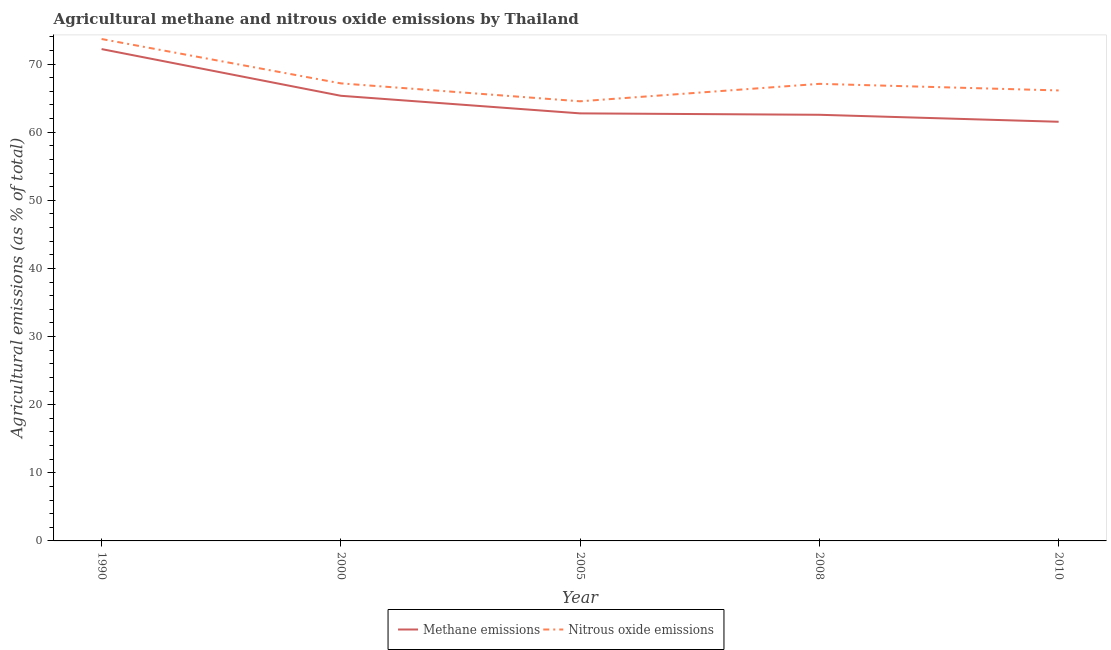How many different coloured lines are there?
Keep it short and to the point. 2. What is the amount of nitrous oxide emissions in 1990?
Keep it short and to the point. 73.67. Across all years, what is the maximum amount of methane emissions?
Make the answer very short. 72.19. Across all years, what is the minimum amount of nitrous oxide emissions?
Make the answer very short. 64.53. In which year was the amount of methane emissions minimum?
Provide a short and direct response. 2010. What is the total amount of nitrous oxide emissions in the graph?
Make the answer very short. 338.58. What is the difference between the amount of nitrous oxide emissions in 1990 and that in 2010?
Keep it short and to the point. 7.55. What is the difference between the amount of methane emissions in 2008 and the amount of nitrous oxide emissions in 2010?
Your answer should be compact. -3.57. What is the average amount of nitrous oxide emissions per year?
Give a very brief answer. 67.72. In the year 2008, what is the difference between the amount of nitrous oxide emissions and amount of methane emissions?
Offer a terse response. 4.54. In how many years, is the amount of methane emissions greater than 72 %?
Offer a very short reply. 1. What is the ratio of the amount of methane emissions in 1990 to that in 2005?
Ensure brevity in your answer.  1.15. Is the amount of nitrous oxide emissions in 1990 less than that in 2010?
Offer a very short reply. No. What is the difference between the highest and the second highest amount of nitrous oxide emissions?
Keep it short and to the point. 6.51. What is the difference between the highest and the lowest amount of nitrous oxide emissions?
Provide a succinct answer. 9.14. In how many years, is the amount of methane emissions greater than the average amount of methane emissions taken over all years?
Your answer should be very brief. 2. Is the sum of the amount of methane emissions in 2000 and 2005 greater than the maximum amount of nitrous oxide emissions across all years?
Offer a very short reply. Yes. Does the amount of methane emissions monotonically increase over the years?
Your answer should be very brief. No. Does the graph contain grids?
Your answer should be compact. No. Where does the legend appear in the graph?
Provide a short and direct response. Bottom center. How many legend labels are there?
Your answer should be very brief. 2. How are the legend labels stacked?
Give a very brief answer. Horizontal. What is the title of the graph?
Make the answer very short. Agricultural methane and nitrous oxide emissions by Thailand. What is the label or title of the X-axis?
Your answer should be compact. Year. What is the label or title of the Y-axis?
Your answer should be very brief. Agricultural emissions (as % of total). What is the Agricultural emissions (as % of total) in Methane emissions in 1990?
Provide a short and direct response. 72.19. What is the Agricultural emissions (as % of total) of Nitrous oxide emissions in 1990?
Offer a very short reply. 73.67. What is the Agricultural emissions (as % of total) in Methane emissions in 2000?
Offer a very short reply. 65.34. What is the Agricultural emissions (as % of total) of Nitrous oxide emissions in 2000?
Your answer should be very brief. 67.16. What is the Agricultural emissions (as % of total) of Methane emissions in 2005?
Your response must be concise. 62.76. What is the Agricultural emissions (as % of total) in Nitrous oxide emissions in 2005?
Give a very brief answer. 64.53. What is the Agricultural emissions (as % of total) in Methane emissions in 2008?
Offer a very short reply. 62.55. What is the Agricultural emissions (as % of total) of Nitrous oxide emissions in 2008?
Provide a succinct answer. 67.09. What is the Agricultural emissions (as % of total) of Methane emissions in 2010?
Provide a short and direct response. 61.53. What is the Agricultural emissions (as % of total) of Nitrous oxide emissions in 2010?
Make the answer very short. 66.12. Across all years, what is the maximum Agricultural emissions (as % of total) in Methane emissions?
Your answer should be very brief. 72.19. Across all years, what is the maximum Agricultural emissions (as % of total) in Nitrous oxide emissions?
Offer a terse response. 73.67. Across all years, what is the minimum Agricultural emissions (as % of total) in Methane emissions?
Offer a terse response. 61.53. Across all years, what is the minimum Agricultural emissions (as % of total) of Nitrous oxide emissions?
Your answer should be very brief. 64.53. What is the total Agricultural emissions (as % of total) in Methane emissions in the graph?
Provide a short and direct response. 324.37. What is the total Agricultural emissions (as % of total) in Nitrous oxide emissions in the graph?
Ensure brevity in your answer.  338.58. What is the difference between the Agricultural emissions (as % of total) in Methane emissions in 1990 and that in 2000?
Make the answer very short. 6.85. What is the difference between the Agricultural emissions (as % of total) in Nitrous oxide emissions in 1990 and that in 2000?
Keep it short and to the point. 6.51. What is the difference between the Agricultural emissions (as % of total) of Methane emissions in 1990 and that in 2005?
Give a very brief answer. 9.44. What is the difference between the Agricultural emissions (as % of total) of Nitrous oxide emissions in 1990 and that in 2005?
Your response must be concise. 9.14. What is the difference between the Agricultural emissions (as % of total) in Methane emissions in 1990 and that in 2008?
Offer a very short reply. 9.64. What is the difference between the Agricultural emissions (as % of total) in Nitrous oxide emissions in 1990 and that in 2008?
Give a very brief answer. 6.58. What is the difference between the Agricultural emissions (as % of total) in Methane emissions in 1990 and that in 2010?
Your answer should be compact. 10.67. What is the difference between the Agricultural emissions (as % of total) in Nitrous oxide emissions in 1990 and that in 2010?
Your answer should be compact. 7.55. What is the difference between the Agricultural emissions (as % of total) of Methane emissions in 2000 and that in 2005?
Provide a succinct answer. 2.58. What is the difference between the Agricultural emissions (as % of total) in Nitrous oxide emissions in 2000 and that in 2005?
Ensure brevity in your answer.  2.63. What is the difference between the Agricultural emissions (as % of total) in Methane emissions in 2000 and that in 2008?
Ensure brevity in your answer.  2.79. What is the difference between the Agricultural emissions (as % of total) in Nitrous oxide emissions in 2000 and that in 2008?
Offer a terse response. 0.07. What is the difference between the Agricultural emissions (as % of total) in Methane emissions in 2000 and that in 2010?
Make the answer very short. 3.81. What is the difference between the Agricultural emissions (as % of total) of Nitrous oxide emissions in 2000 and that in 2010?
Offer a very short reply. 1.04. What is the difference between the Agricultural emissions (as % of total) of Methane emissions in 2005 and that in 2008?
Ensure brevity in your answer.  0.21. What is the difference between the Agricultural emissions (as % of total) in Nitrous oxide emissions in 2005 and that in 2008?
Provide a succinct answer. -2.56. What is the difference between the Agricultural emissions (as % of total) in Methane emissions in 2005 and that in 2010?
Give a very brief answer. 1.23. What is the difference between the Agricultural emissions (as % of total) of Nitrous oxide emissions in 2005 and that in 2010?
Ensure brevity in your answer.  -1.59. What is the difference between the Agricultural emissions (as % of total) of Methane emissions in 2008 and that in 2010?
Offer a very short reply. 1.02. What is the difference between the Agricultural emissions (as % of total) in Nitrous oxide emissions in 2008 and that in 2010?
Provide a short and direct response. 0.97. What is the difference between the Agricultural emissions (as % of total) of Methane emissions in 1990 and the Agricultural emissions (as % of total) of Nitrous oxide emissions in 2000?
Offer a very short reply. 5.03. What is the difference between the Agricultural emissions (as % of total) in Methane emissions in 1990 and the Agricultural emissions (as % of total) in Nitrous oxide emissions in 2005?
Your response must be concise. 7.66. What is the difference between the Agricultural emissions (as % of total) of Methane emissions in 1990 and the Agricultural emissions (as % of total) of Nitrous oxide emissions in 2008?
Offer a terse response. 5.1. What is the difference between the Agricultural emissions (as % of total) of Methane emissions in 1990 and the Agricultural emissions (as % of total) of Nitrous oxide emissions in 2010?
Give a very brief answer. 6.07. What is the difference between the Agricultural emissions (as % of total) in Methane emissions in 2000 and the Agricultural emissions (as % of total) in Nitrous oxide emissions in 2005?
Provide a short and direct response. 0.81. What is the difference between the Agricultural emissions (as % of total) in Methane emissions in 2000 and the Agricultural emissions (as % of total) in Nitrous oxide emissions in 2008?
Your response must be concise. -1.75. What is the difference between the Agricultural emissions (as % of total) in Methane emissions in 2000 and the Agricultural emissions (as % of total) in Nitrous oxide emissions in 2010?
Offer a very short reply. -0.78. What is the difference between the Agricultural emissions (as % of total) in Methane emissions in 2005 and the Agricultural emissions (as % of total) in Nitrous oxide emissions in 2008?
Your answer should be compact. -4.33. What is the difference between the Agricultural emissions (as % of total) of Methane emissions in 2005 and the Agricultural emissions (as % of total) of Nitrous oxide emissions in 2010?
Give a very brief answer. -3.37. What is the difference between the Agricultural emissions (as % of total) in Methane emissions in 2008 and the Agricultural emissions (as % of total) in Nitrous oxide emissions in 2010?
Your answer should be very brief. -3.57. What is the average Agricultural emissions (as % of total) of Methane emissions per year?
Keep it short and to the point. 64.87. What is the average Agricultural emissions (as % of total) of Nitrous oxide emissions per year?
Offer a terse response. 67.72. In the year 1990, what is the difference between the Agricultural emissions (as % of total) of Methane emissions and Agricultural emissions (as % of total) of Nitrous oxide emissions?
Offer a terse response. -1.48. In the year 2000, what is the difference between the Agricultural emissions (as % of total) of Methane emissions and Agricultural emissions (as % of total) of Nitrous oxide emissions?
Provide a succinct answer. -1.82. In the year 2005, what is the difference between the Agricultural emissions (as % of total) in Methane emissions and Agricultural emissions (as % of total) in Nitrous oxide emissions?
Offer a very short reply. -1.77. In the year 2008, what is the difference between the Agricultural emissions (as % of total) of Methane emissions and Agricultural emissions (as % of total) of Nitrous oxide emissions?
Your answer should be very brief. -4.54. In the year 2010, what is the difference between the Agricultural emissions (as % of total) of Methane emissions and Agricultural emissions (as % of total) of Nitrous oxide emissions?
Offer a very short reply. -4.6. What is the ratio of the Agricultural emissions (as % of total) in Methane emissions in 1990 to that in 2000?
Keep it short and to the point. 1.1. What is the ratio of the Agricultural emissions (as % of total) in Nitrous oxide emissions in 1990 to that in 2000?
Ensure brevity in your answer.  1.1. What is the ratio of the Agricultural emissions (as % of total) of Methane emissions in 1990 to that in 2005?
Provide a short and direct response. 1.15. What is the ratio of the Agricultural emissions (as % of total) of Nitrous oxide emissions in 1990 to that in 2005?
Your answer should be compact. 1.14. What is the ratio of the Agricultural emissions (as % of total) in Methane emissions in 1990 to that in 2008?
Your answer should be very brief. 1.15. What is the ratio of the Agricultural emissions (as % of total) of Nitrous oxide emissions in 1990 to that in 2008?
Offer a terse response. 1.1. What is the ratio of the Agricultural emissions (as % of total) of Methane emissions in 1990 to that in 2010?
Ensure brevity in your answer.  1.17. What is the ratio of the Agricultural emissions (as % of total) of Nitrous oxide emissions in 1990 to that in 2010?
Make the answer very short. 1.11. What is the ratio of the Agricultural emissions (as % of total) in Methane emissions in 2000 to that in 2005?
Give a very brief answer. 1.04. What is the ratio of the Agricultural emissions (as % of total) of Nitrous oxide emissions in 2000 to that in 2005?
Your response must be concise. 1.04. What is the ratio of the Agricultural emissions (as % of total) of Methane emissions in 2000 to that in 2008?
Ensure brevity in your answer.  1.04. What is the ratio of the Agricultural emissions (as % of total) in Methane emissions in 2000 to that in 2010?
Keep it short and to the point. 1.06. What is the ratio of the Agricultural emissions (as % of total) of Nitrous oxide emissions in 2000 to that in 2010?
Give a very brief answer. 1.02. What is the ratio of the Agricultural emissions (as % of total) of Methane emissions in 2005 to that in 2008?
Provide a succinct answer. 1. What is the ratio of the Agricultural emissions (as % of total) in Nitrous oxide emissions in 2005 to that in 2008?
Offer a terse response. 0.96. What is the ratio of the Agricultural emissions (as % of total) in Methane emissions in 2005 to that in 2010?
Your answer should be very brief. 1.02. What is the ratio of the Agricultural emissions (as % of total) of Nitrous oxide emissions in 2005 to that in 2010?
Your answer should be compact. 0.98. What is the ratio of the Agricultural emissions (as % of total) of Methane emissions in 2008 to that in 2010?
Your answer should be compact. 1.02. What is the ratio of the Agricultural emissions (as % of total) in Nitrous oxide emissions in 2008 to that in 2010?
Ensure brevity in your answer.  1.01. What is the difference between the highest and the second highest Agricultural emissions (as % of total) of Methane emissions?
Make the answer very short. 6.85. What is the difference between the highest and the second highest Agricultural emissions (as % of total) in Nitrous oxide emissions?
Ensure brevity in your answer.  6.51. What is the difference between the highest and the lowest Agricultural emissions (as % of total) in Methane emissions?
Make the answer very short. 10.67. What is the difference between the highest and the lowest Agricultural emissions (as % of total) in Nitrous oxide emissions?
Provide a short and direct response. 9.14. 